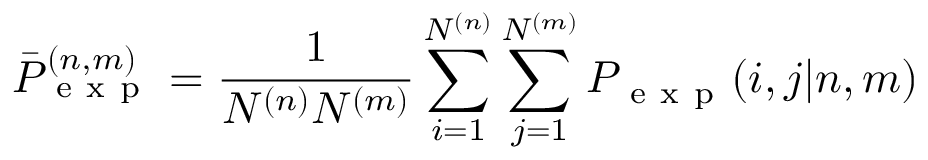<formula> <loc_0><loc_0><loc_500><loc_500>\bar { P } _ { e x p } ^ { ( n , m ) } = \frac { 1 } { N ^ { ( n ) } N ^ { ( m ) } } \sum _ { i = 1 } ^ { N ^ { ( n ) } } \sum _ { j = 1 } ^ { N ^ { ( m ) } } P _ { e x p } ( i , j | n , m )</formula> 